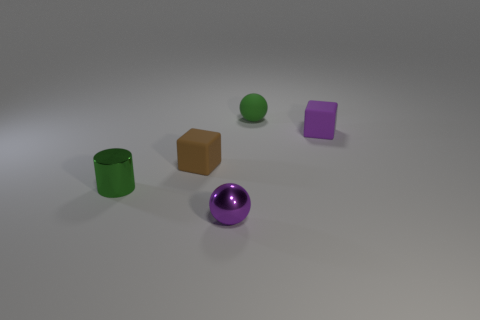There is a object that is in front of the green rubber sphere and behind the brown rubber cube; what material is it made of?
Your answer should be compact. Rubber. Is the number of brown objects greater than the number of big blue rubber blocks?
Keep it short and to the point. Yes. The shiny object to the left of the purple thing that is left of the small cube that is right of the tiny metal ball is what color?
Your answer should be compact. Green. Is the tiny green object that is behind the green cylinder made of the same material as the small green cylinder?
Provide a succinct answer. No. Are there any metal cylinders of the same color as the metallic sphere?
Provide a short and direct response. No. Are any yellow rubber blocks visible?
Offer a very short reply. No. Does the brown matte thing that is left of the green rubber object have the same size as the green metallic cylinder?
Offer a terse response. Yes. Is the number of small cubes less than the number of blue metal cubes?
Your answer should be very brief. No. The object that is to the right of the tiny green object behind the small green thing that is in front of the small green matte sphere is what shape?
Offer a very short reply. Cube. Is there a green cylinder made of the same material as the small purple cube?
Your answer should be compact. No. 